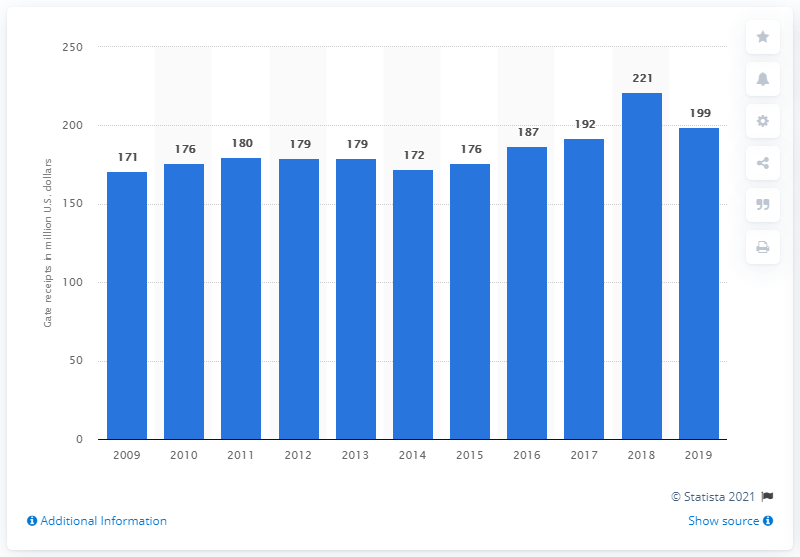Give some essential details in this illustration. The gate receipts of the Boston Red Sox in 2019 were 199... 